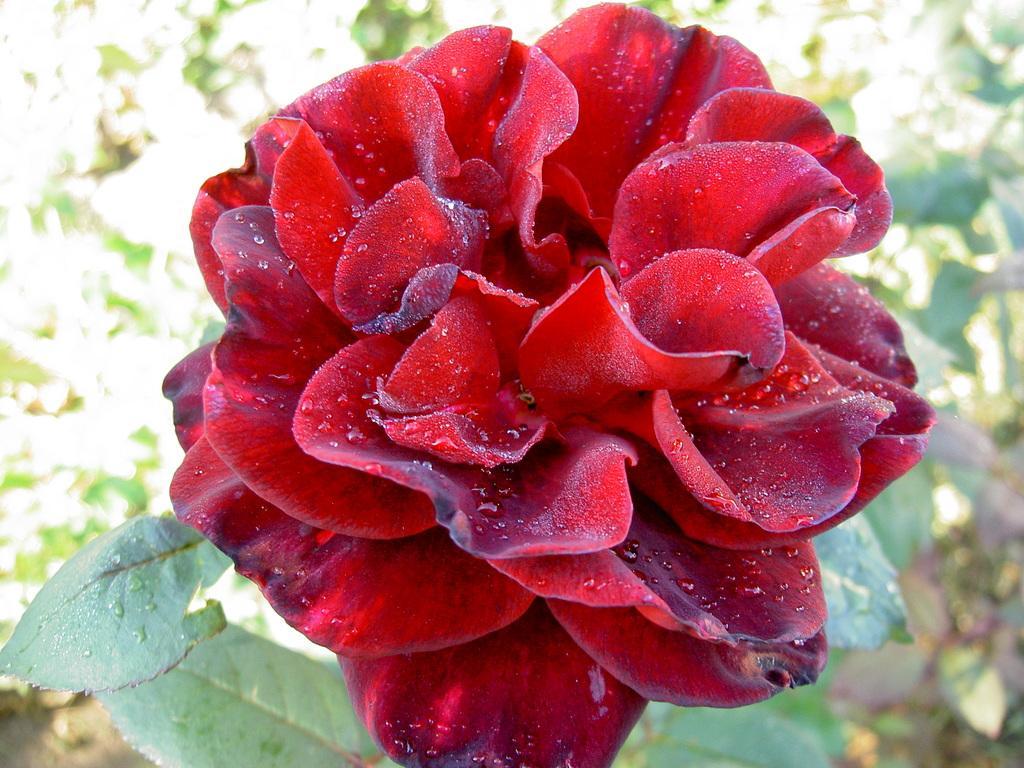Please provide a concise description of this image. In this image we can see one plant with red flower and background some plants on the surface. 